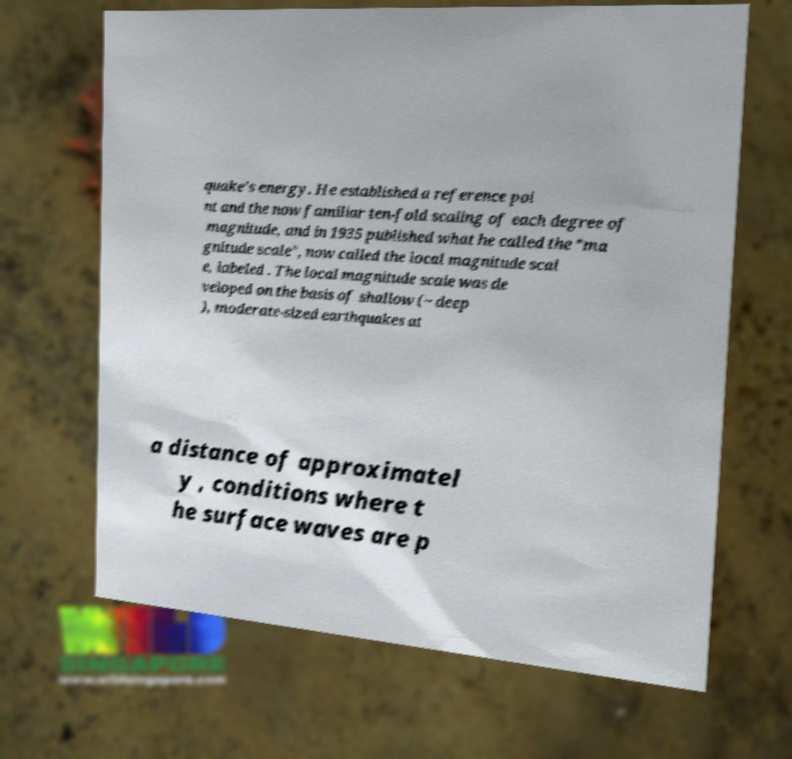Please identify and transcribe the text found in this image. quake's energy. He established a reference poi nt and the now familiar ten-fold scaling of each degree of magnitude, and in 1935 published what he called the "ma gnitude scale", now called the local magnitude scal e, labeled . The local magnitude scale was de veloped on the basis of shallow (~ deep ), moderate-sized earthquakes at a distance of approximatel y , conditions where t he surface waves are p 